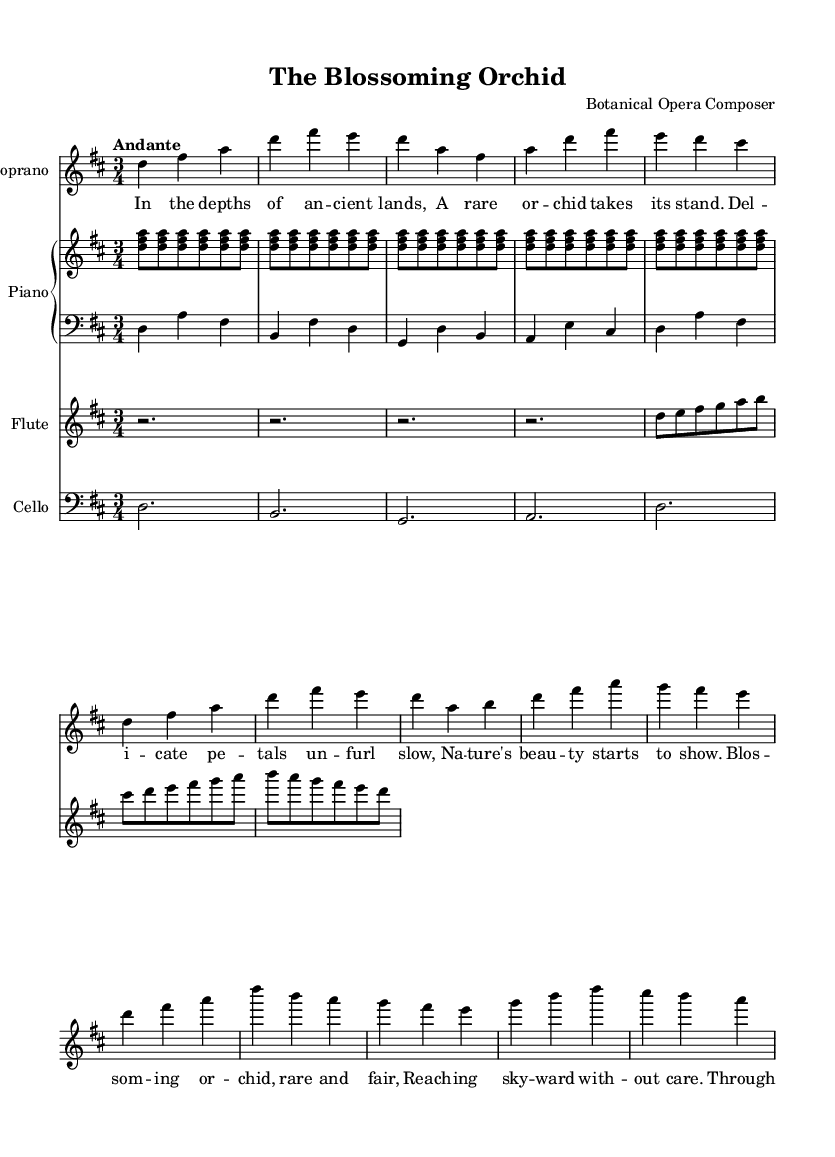What is the key signature of this music? The key signature is indicated at the beginning of the staff. It shows two sharps, which correspond to F# and C#. This means the music is in D major.
Answer: D major What is the time signature of the piece? The time signature is found at the beginning of the score, immediately after the key signature. Here, it is indicated as 3/4, meaning there are three beats per measure and the quarter note gets one beat.
Answer: 3/4 What is the tempo marking in the score? The tempo marking is specified as "Andante." This term describes the speed of the music, typically indicating a moderately slow pace.
Answer: Andante How many measures does the soprano part have? The soprano part consists of 12 measures, starting from the first note until the end of the last line of the score.
Answer: 12 What instruments are featured in this opera? The score indicates several instruments. By observing the parts labeled at the beginning of each staff, we see Soprano, Piano (with both RH and LH), Flute, and Cello as featured instruments.
Answer: Soprano, Piano, Flute, Cello What themes are explored in the lyrics of this opera? The lyrics describe the blooming of a rare orchid and reflect on nature's beauty and its cycles. The lyrics discuss the delicate unfolding of petals and the perseverance of nature through sun and rain.
Answer: Botanical themes and beauty of nature 